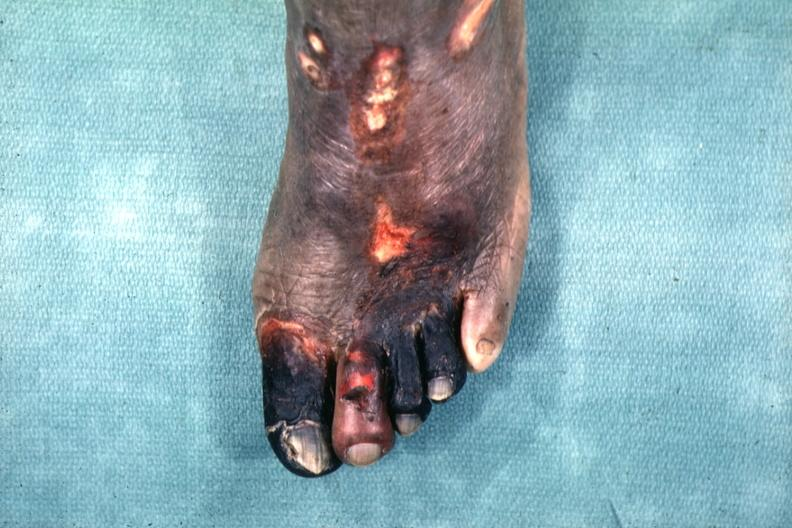does this image show excellent example of gangrene of the first four toes?
Answer the question using a single word or phrase. Yes 